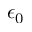<formula> <loc_0><loc_0><loc_500><loc_500>\epsilon _ { 0 }</formula> 